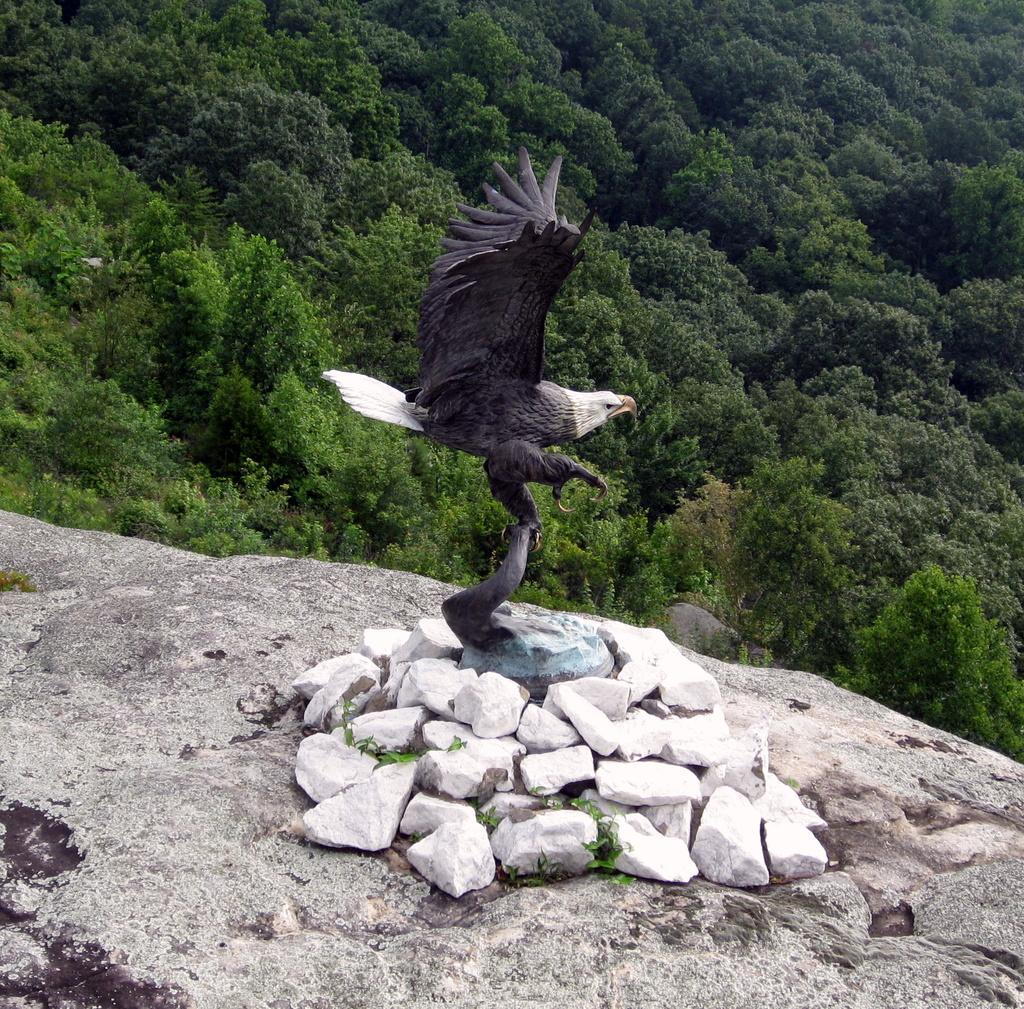Describe this image in one or two sentences. Here we can see birds and there are stones. In the background we can see trees. 